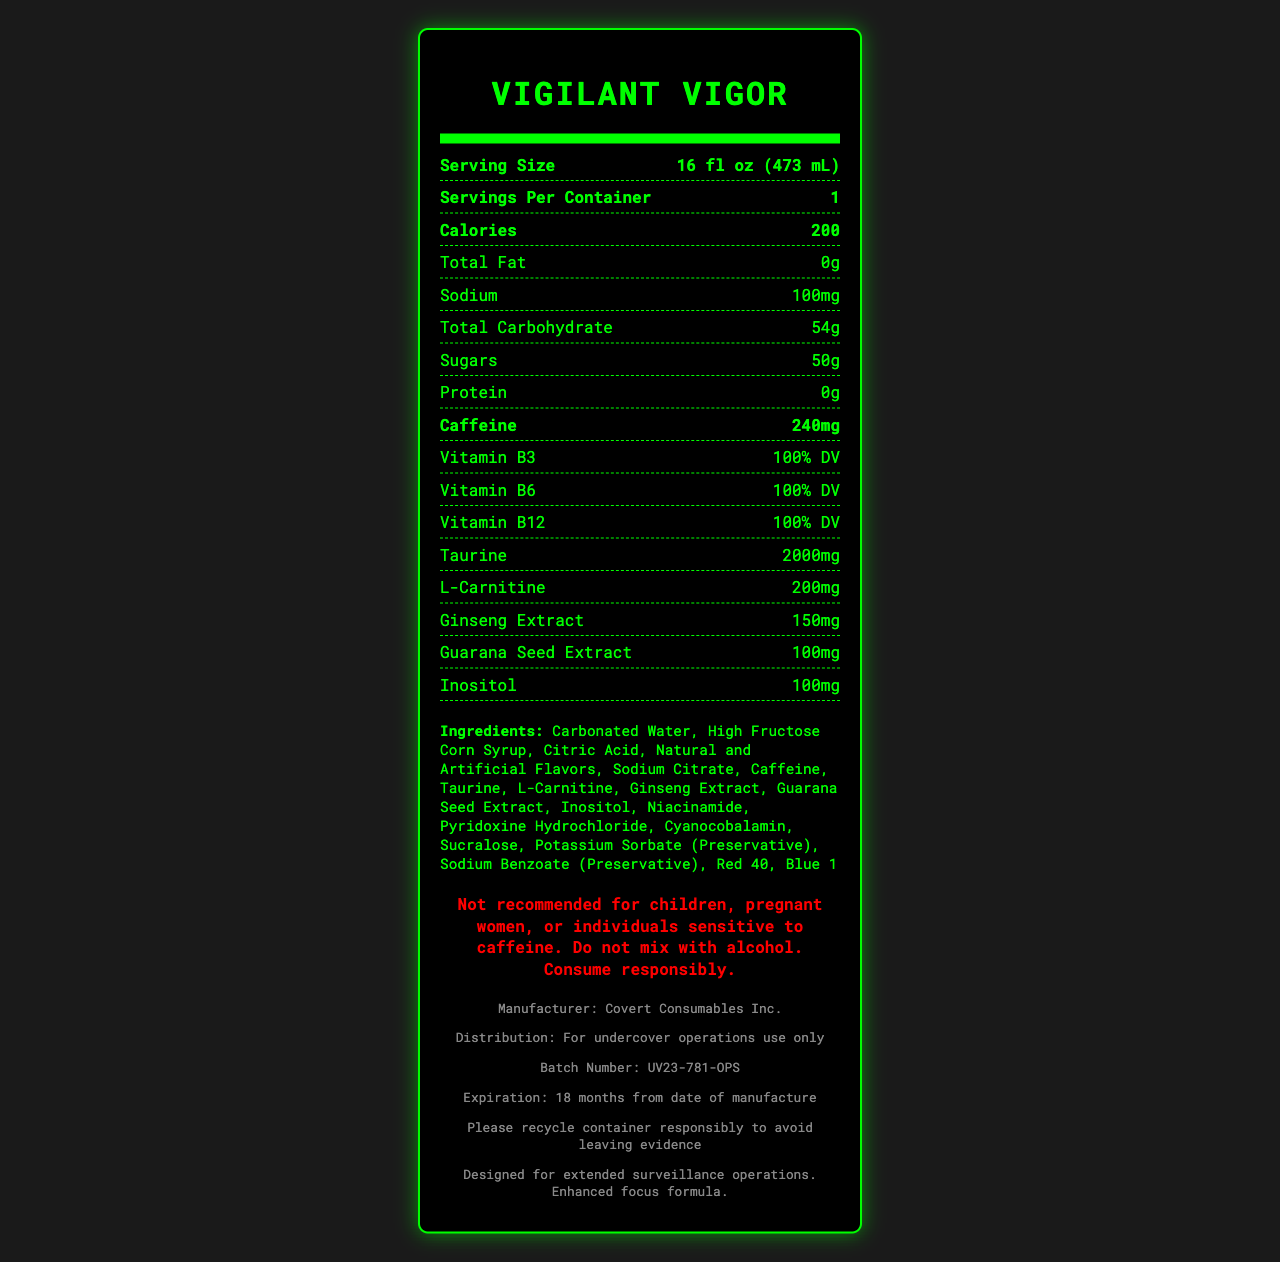what is the serving size of Vigilant Vigor? The serving size is located at the top of the nutrition facts, following the heading "Serving Size".
Answer: 16 fl oz (473 mL) how much caffeine is in one serving of this energy drink? The caffeine content is highlighted in bold within the nutrition facts section.
Answer: 240mg what is the sodium content per serving? The sodium content is listed in the nutrition facts under "Sodium".
Answer: 100mg how many grams of sugars does this drink contain? The sugar content is listed under the "Sugars" section within the nutrition facts.
Answer: 50g who is the manufacturer of this product? The manufacturer's name is provided in the additional info section near the bottom of the document.
Answer: Covert Consumables Inc. what is the purpose of this product? A. Daily hydration B. Extended surveillance operations C. General energy boost The additional info section states that the drink is designed for "extended surveillance operations".
Answer: B which of these ingredients is the main ingredient? I. Carbonated Water II. High Fructose Corn Syrup III. Citric Acid The ingredients list specifies that "Carbonated Water" is the first ingredient, making it the main ingredient.
Answer: I is this drink recommended for children? The warning specifically states "Not recommended for children".
Answer: No summarize the main idea of the document. The document provides comprehensive information about the nutrition facts, ingredients, warnings, manufacturer, and intended use of the energy drink.
Answer: Vigilant Vigor is a caffeine-rich energy drink designed for extended surveillance operations, manufactured by Covert Consumables Inc., with detailed nutrition facts including high levels of caffeine, vitamins, and additional performance-enhancing ingredients. what is the expiration date of this batch? The expiration date is mentioned in the additional info section at the bottom of the document.
Answer: 18 months from date of manufacture what does the recycling info advise? The recycling info is found in the additional info section and advises responsible recycling to avoid leaving evidence.
Answer: Please recycle container responsibly to avoid leaving evidence how many milligrams of taurine are included in this drink? Taurine content is listed in the nutrition facts section.
Answer: 2000mg what are the artificial ingredients mentioned? The artificial ingredients are listed in the ingredient list section.
Answer: Artificial Flavors, Artificial Colors can this document inform about the retail price of Vigilant Vigor? The document does not provide any information regarding the retail price of the product.
Answer: Cannot be determined 